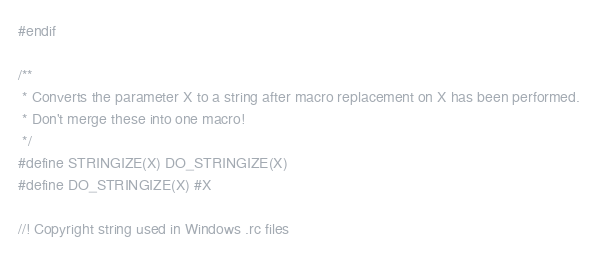Convert code to text. <code><loc_0><loc_0><loc_500><loc_500><_C_>#endif

/**
 * Converts the parameter X to a string after macro replacement on X has been performed.
 * Don't merge these into one macro!
 */
#define STRINGIZE(X) DO_STRINGIZE(X)
#define DO_STRINGIZE(X) #X

//! Copyright string used in Windows .rc files</code> 